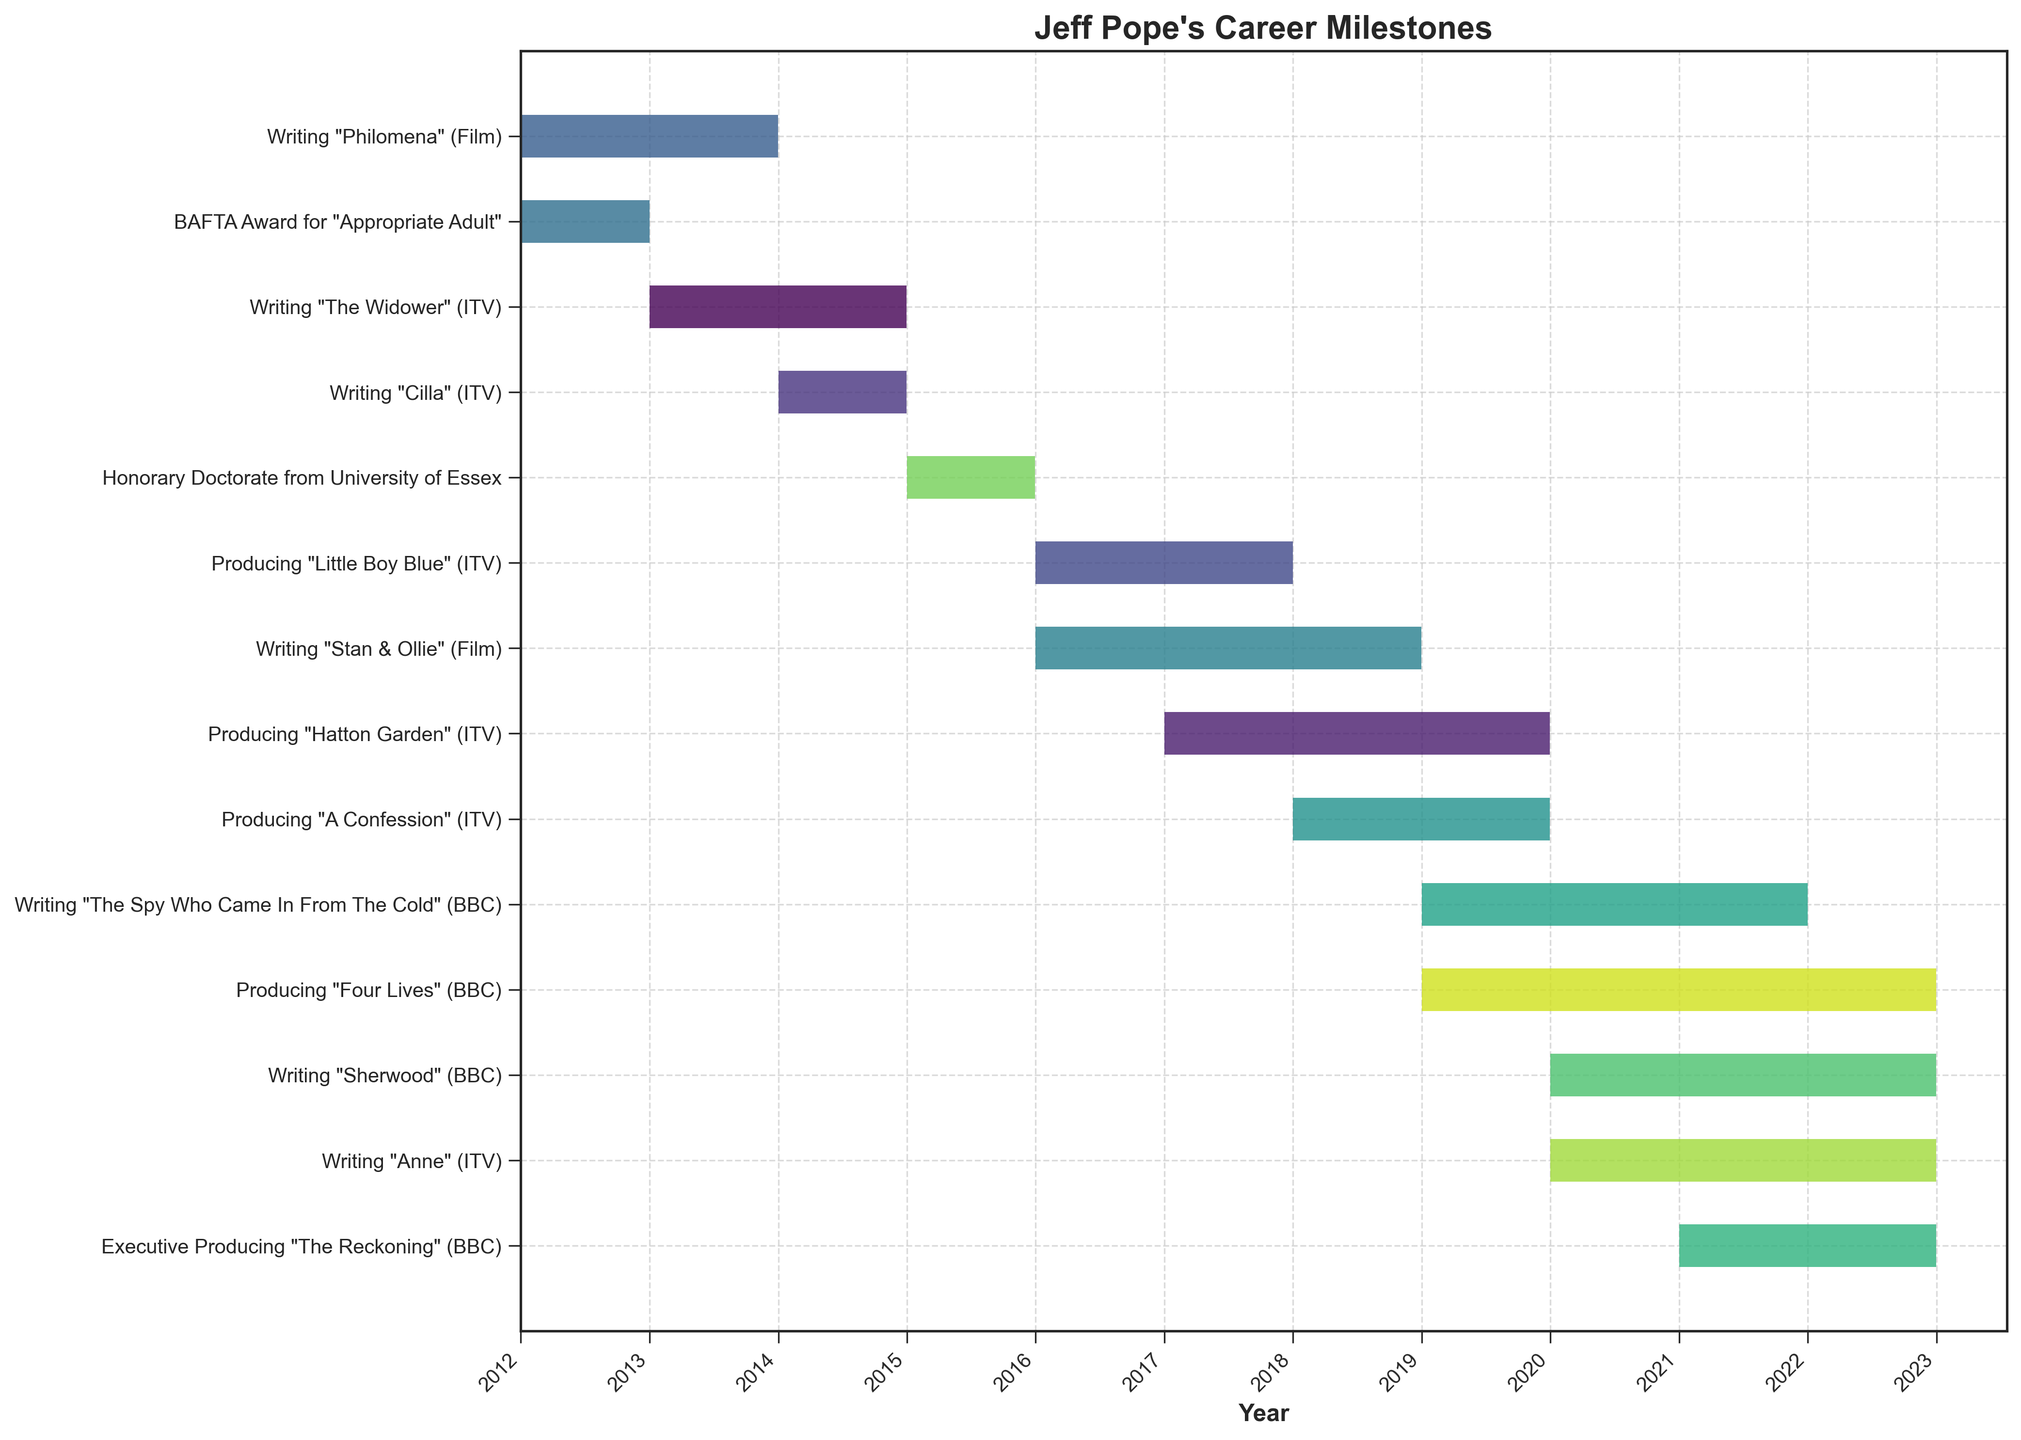What's the title of the chart? The title is usually displayed prominently at the top of the chart. It summarizes the overall content of the chart. In this case, the title is clearly shown.
Answer: Jeff Pope's Career Milestones What is the earliest milestone in Jeff Pope's career according to the chart? By looking at the start dates on the Gantt Chart, we can find the earliest task. "Philomena" (Film) writing began in 2012, which is the earliest.
Answer: Writing "Philomena" (Film), 2012 How many tasks did Jeff Pope work on simultaneously during 2021? In 2021, we observe overlapping tasks to determine the number of concurrent activities. Jeff Pope was working on writing "The Spy Who Came In From The Cold" (BBC), writing "Sherwood" (BBC), writing "Anne" (ITV), producing "Four Lives" (BBC), and executive producing "The Reckoning" (BBC). This totals five tasks.
Answer: Five tasks What roles did Jeff Pope take on in 2019? By looking at the Gantt chart for the year 2019, we identify all tasks that overlap with this period. Jeff Pope was producing "Four Lives" (BBC), producing "A Confession" (ITV), writing "The Spy Who Came In From The Cold" (BBC), and writing "Anne" (ITV).
Answer: Four roles Which task has the longest duration according to the chart? To identify the longest duration, we subtract the start date from the end date for all tasks. "The Spy Who Came In From The Cold" (BBC) has the longest duration from 2019 to 2021, totaling three years.
Answer: Writing "The Spy Who Came In From The Cold" (BBC) Which tasks overlap the duration of "Stan & Ollie" (Film)? "Stan & Ollie" (Film) spans from 2016 to 2018. By identifying other tasks within this period, we find that producing "Little Boy Blue" (ITV) and producing "Four Lives" (BBC) overlap with this task's duration.
Answer: Producing "Little Boy Blue" (ITV), Producing "Four Lives" (BBC) Are there any milestones that took place within a single year according to the chart? If so, which ones? By checking tasks with identical start and end years, we identify: BAFTA Award for "Appropriate Adult" (2012), writing "Cilla" (ITV) (2014), and the Honorary Doctorate from University of Essex (2015).
Answer: BAFTA Award for "Appropriate Adult", Writing "Cilla" (ITV), Honorary Doctorate from University of Essex During which years did Jeff Pope receive awards or honors, according to the chart? We look for any tasks labeled as awards or honors and identify their years. Jeff Pope received the BAFTA Award in 2012 and an Honorary Doctorate in 2015.
Answer: 2012, 2015 What is the latest milestone on the chart? By checking the end dates, the most recent task is writing "Sherwood" (BBC) and writing "Anne" (ITV), both ending in 2022.
Answer: Writing "Sherwood" (BBC), Writing "Anne" (ITV) 